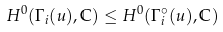<formula> <loc_0><loc_0><loc_500><loc_500>H ^ { 0 } ( \Gamma _ { i } ( u ) , \mathbb { C } ) \leq H ^ { 0 } ( \Gamma _ { i } ^ { \circ } ( u ) , \mathbb { C } )</formula> 